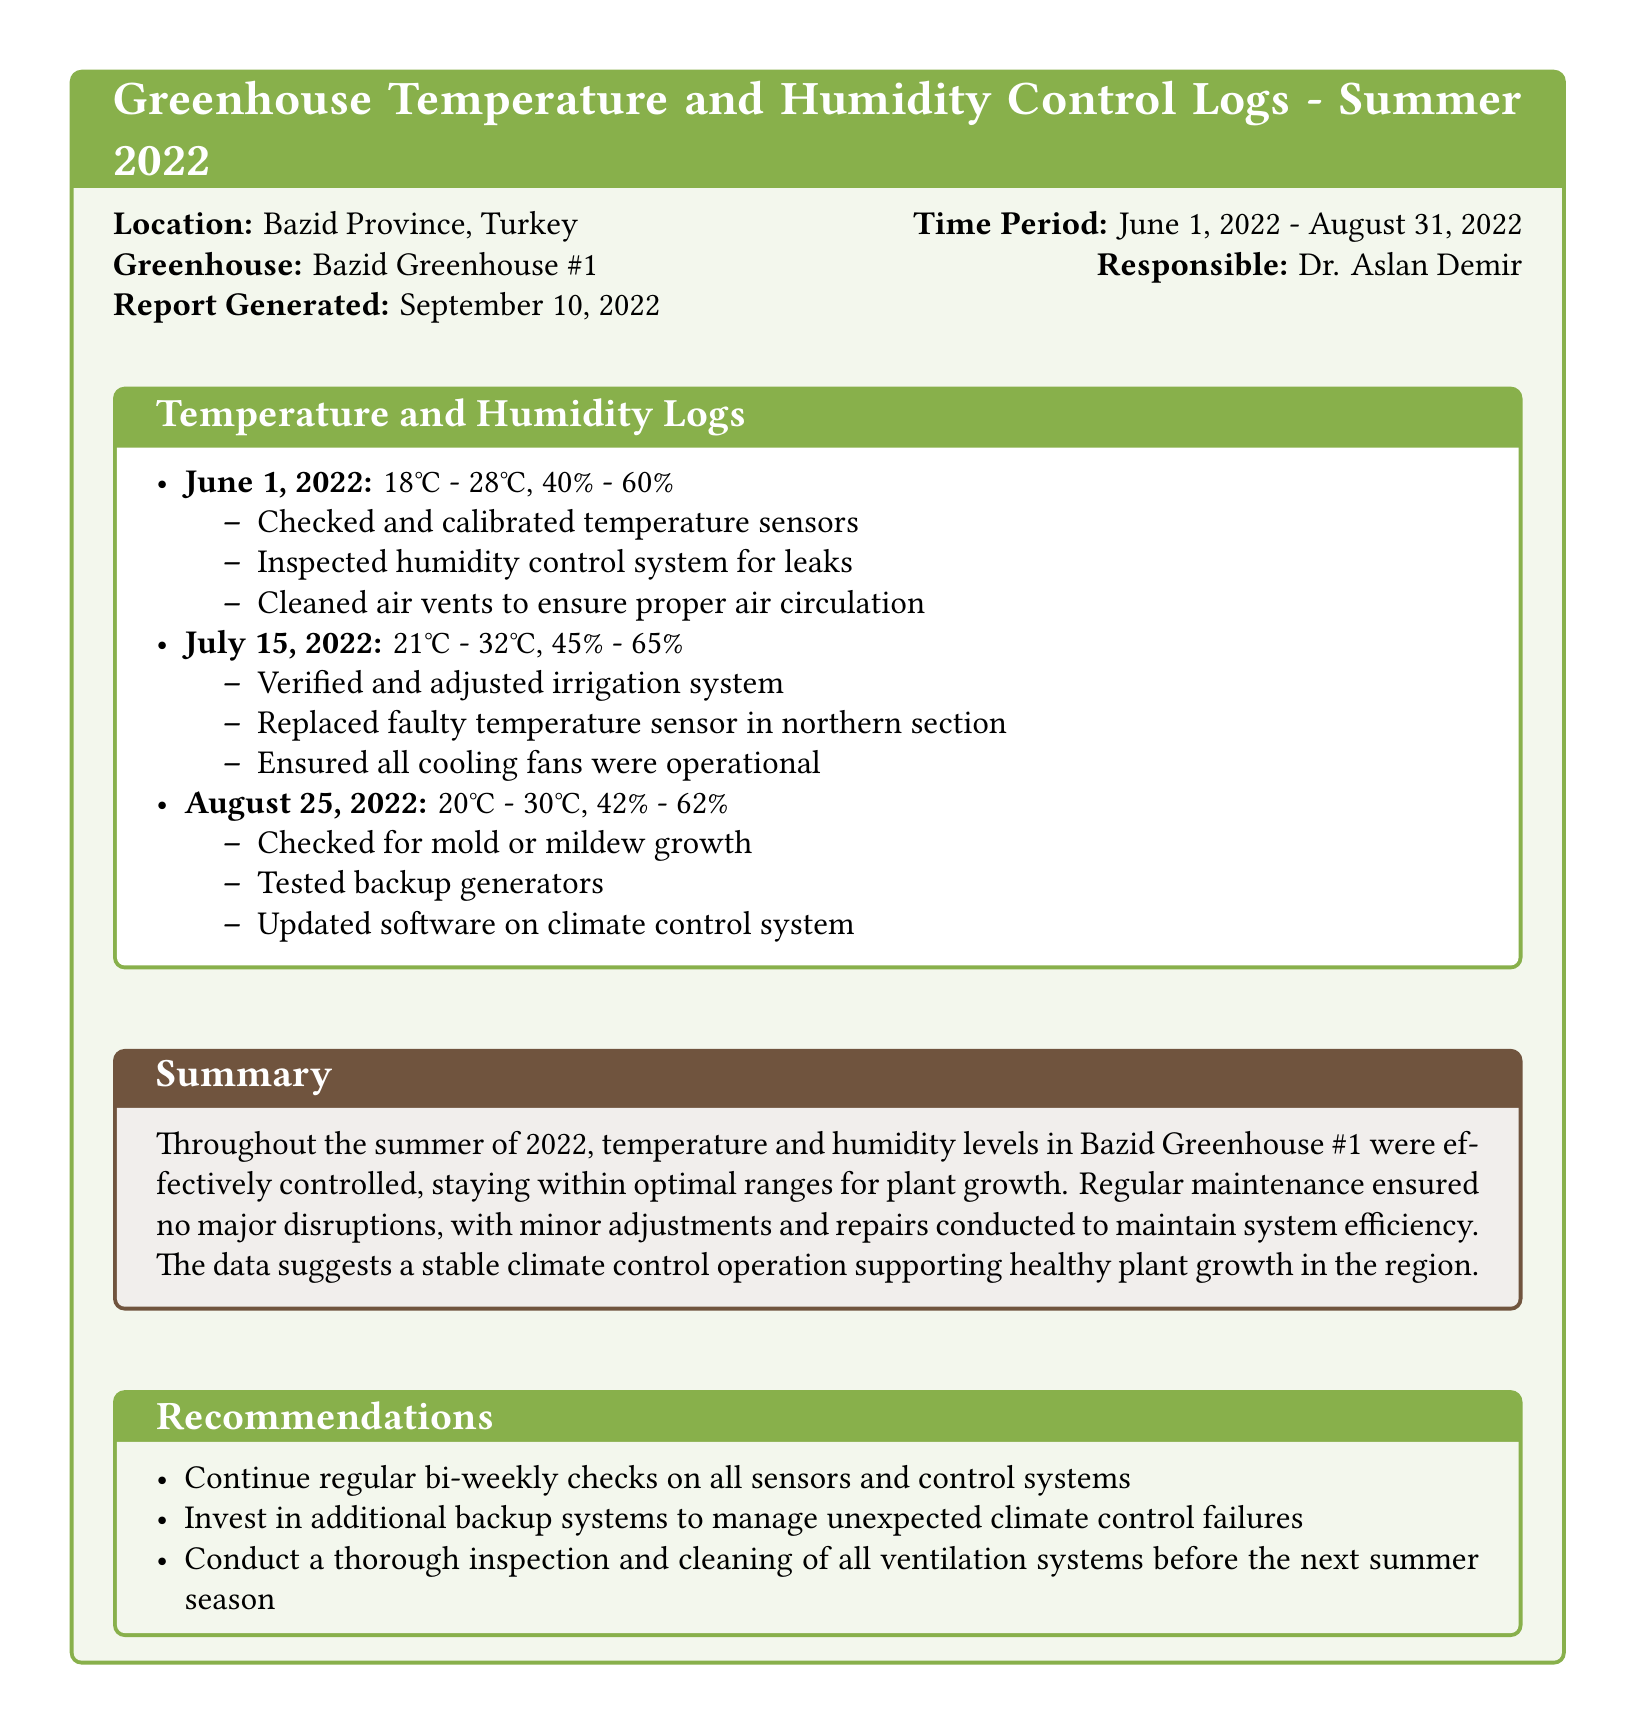what is the temperature range on June 1, 2022? The temperature range recorded on June 1, 2022, was from 18°C to 28°C.
Answer: 18°C - 28°C what is the humidity range on July 15, 2022? The humidity range recorded on July 15, 2022, was from 45% to 65%.
Answer: 45% - 65% who is responsible for the greenhouse? The responsible person for the greenhouse is Dr. Aslan Demir.
Answer: Dr. Aslan Demir which month had a check for mold or mildew growth? A check for mold or mildew growth was conducted in August 2022.
Answer: August 2022 how many times were temperature sensors calibrated or checked in the summer? Temperature sensors were checked and calibrated at least once in June and once in July, totaling two instances.
Answer: 2 what maintenance action was taken on July 15, 2022? A faulty temperature sensor in the northern section was replaced on July 15, 2022.
Answer: Replaced faulty temperature sensor what is one recommendation mentioned in the document? One recommendation stated to continue regular bi-weekly checks on all sensors and control systems.
Answer: Continue regular bi-weekly checks what is the report generation date? The report was generated on September 10, 2022.
Answer: September 10, 2022 what was the summary conclusion regarding climate control operation? The climate control operation was described as stable, supporting healthy plant growth in the region.
Answer: Stable climate control operation 